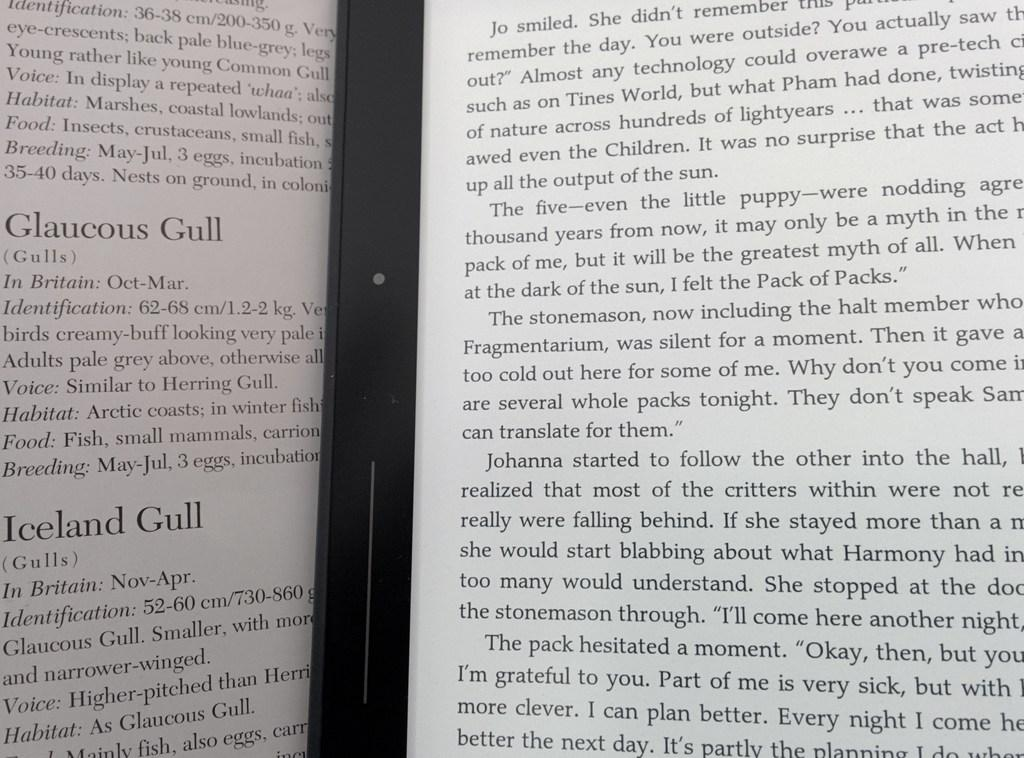<image>
Present a compact description of the photo's key features. An open book describing different kinds of Gulls, like the Iceland Gull or Claucous. 